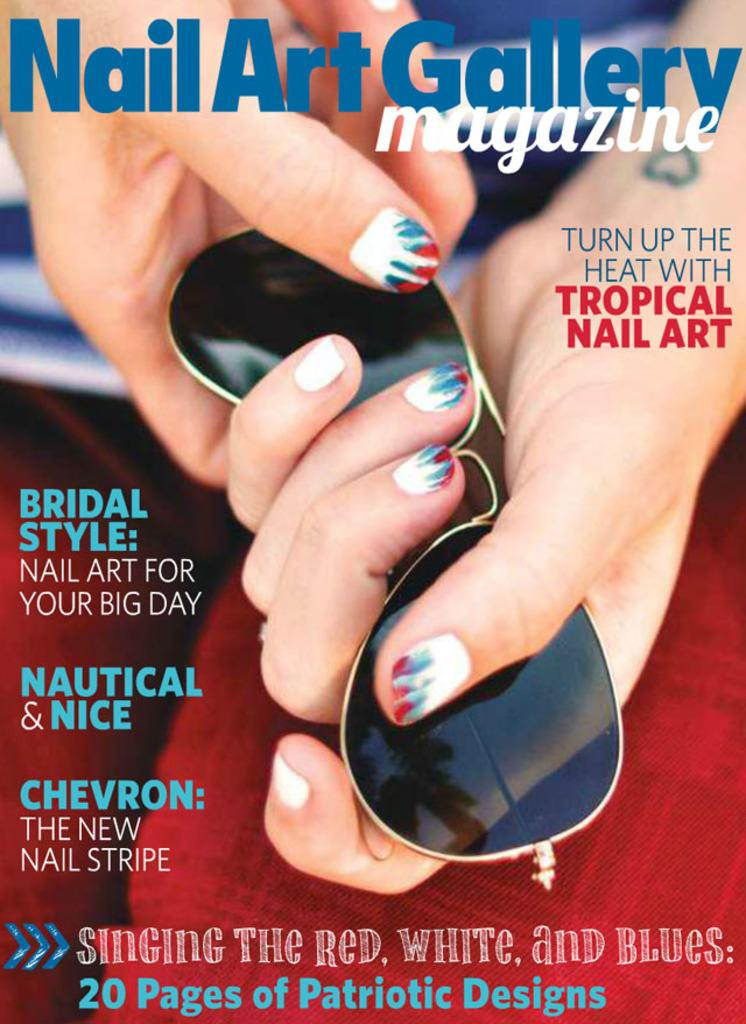Provide a one-sentence caption for the provided image. A Nail Art Gallery Magazine cover with a picture of a woman's hand with red, white and blue manicured nails holding a pair of Wayfair sunglasses. 